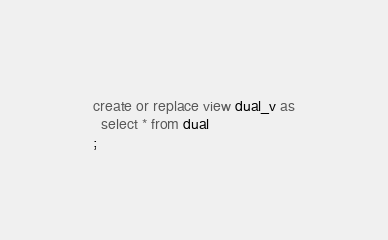<code> <loc_0><loc_0><loc_500><loc_500><_SQL_>create or replace view dual_v as
  select * from dual
;
</code> 